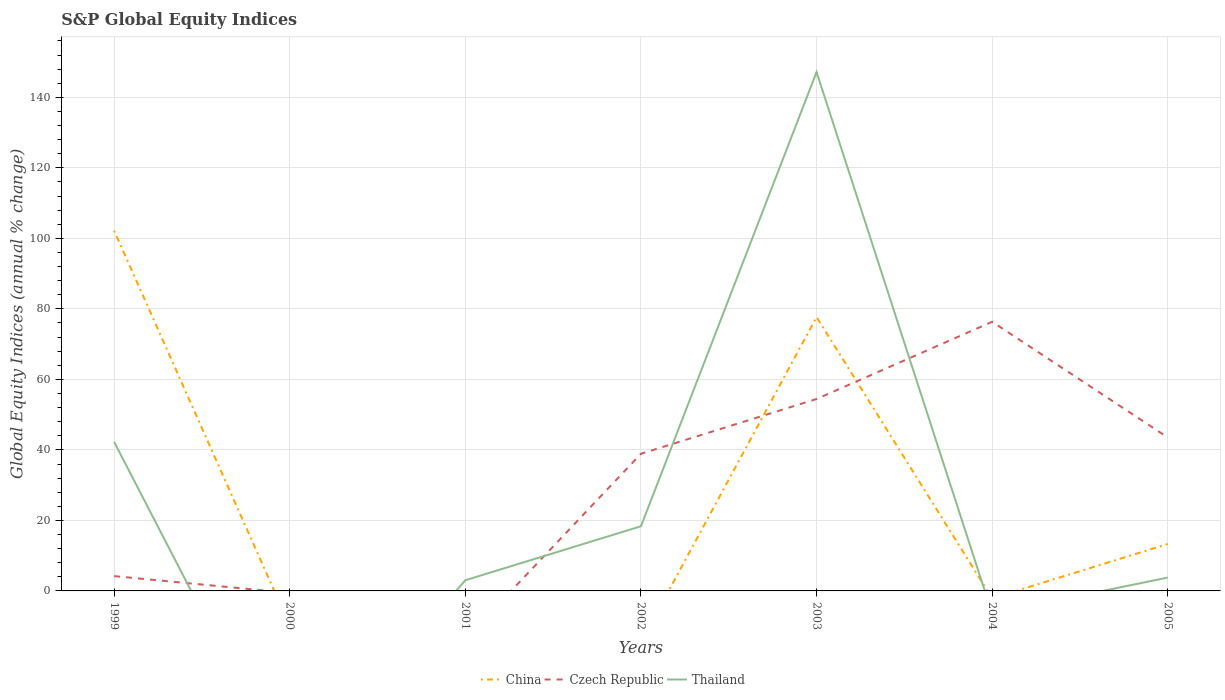Does the line corresponding to Czech Republic intersect with the line corresponding to Thailand?
Your answer should be very brief. Yes. Is the number of lines equal to the number of legend labels?
Offer a very short reply. No. What is the total global equity indices in Thailand in the graph?
Provide a succinct answer. -144.15. What is the difference between the highest and the second highest global equity indices in China?
Offer a very short reply. 102.2. How many lines are there?
Your answer should be compact. 3. How many years are there in the graph?
Provide a succinct answer. 7. Are the values on the major ticks of Y-axis written in scientific E-notation?
Your answer should be very brief. No. Does the graph contain grids?
Offer a terse response. Yes. How many legend labels are there?
Your answer should be compact. 3. How are the legend labels stacked?
Give a very brief answer. Horizontal. What is the title of the graph?
Your answer should be compact. S&P Global Equity Indices. What is the label or title of the X-axis?
Ensure brevity in your answer.  Years. What is the label or title of the Y-axis?
Offer a very short reply. Global Equity Indices (annual % change). What is the Global Equity Indices (annual % change) of China in 1999?
Your answer should be very brief. 102.2. What is the Global Equity Indices (annual % change) of Czech Republic in 1999?
Offer a terse response. 4.2. What is the Global Equity Indices (annual % change) of Thailand in 1999?
Offer a very short reply. 42.3. What is the Global Equity Indices (annual % change) of Thailand in 2000?
Give a very brief answer. 0. What is the Global Equity Indices (annual % change) in China in 2001?
Provide a short and direct response. 0. What is the Global Equity Indices (annual % change) in Thailand in 2001?
Your response must be concise. 3.03. What is the Global Equity Indices (annual % change) of China in 2002?
Your answer should be compact. 0. What is the Global Equity Indices (annual % change) of Czech Republic in 2002?
Provide a short and direct response. 38.9. What is the Global Equity Indices (annual % change) in Thailand in 2002?
Offer a very short reply. 18.34. What is the Global Equity Indices (annual % change) of China in 2003?
Provide a short and direct response. 77.67. What is the Global Equity Indices (annual % change) in Czech Republic in 2003?
Provide a succinct answer. 54.44. What is the Global Equity Indices (annual % change) in Thailand in 2003?
Give a very brief answer. 147.18. What is the Global Equity Indices (annual % change) of Czech Republic in 2004?
Your response must be concise. 76.34. What is the Global Equity Indices (annual % change) of China in 2005?
Make the answer very short. 13.31. What is the Global Equity Indices (annual % change) in Czech Republic in 2005?
Give a very brief answer. 43.52. What is the Global Equity Indices (annual % change) of Thailand in 2005?
Ensure brevity in your answer.  3.79. Across all years, what is the maximum Global Equity Indices (annual % change) of China?
Give a very brief answer. 102.2. Across all years, what is the maximum Global Equity Indices (annual % change) of Czech Republic?
Your answer should be compact. 76.34. Across all years, what is the maximum Global Equity Indices (annual % change) in Thailand?
Your answer should be compact. 147.18. Across all years, what is the minimum Global Equity Indices (annual % change) of China?
Your answer should be very brief. 0. Across all years, what is the minimum Global Equity Indices (annual % change) in Czech Republic?
Provide a short and direct response. 0. What is the total Global Equity Indices (annual % change) in China in the graph?
Make the answer very short. 193.18. What is the total Global Equity Indices (annual % change) in Czech Republic in the graph?
Your answer should be very brief. 217.4. What is the total Global Equity Indices (annual % change) of Thailand in the graph?
Give a very brief answer. 214.64. What is the difference between the Global Equity Indices (annual % change) in Thailand in 1999 and that in 2001?
Ensure brevity in your answer.  39.27. What is the difference between the Global Equity Indices (annual % change) of Czech Republic in 1999 and that in 2002?
Keep it short and to the point. -34.7. What is the difference between the Global Equity Indices (annual % change) of Thailand in 1999 and that in 2002?
Provide a succinct answer. 23.96. What is the difference between the Global Equity Indices (annual % change) in China in 1999 and that in 2003?
Make the answer very short. 24.53. What is the difference between the Global Equity Indices (annual % change) of Czech Republic in 1999 and that in 2003?
Your response must be concise. -50.24. What is the difference between the Global Equity Indices (annual % change) of Thailand in 1999 and that in 2003?
Your answer should be compact. -104.88. What is the difference between the Global Equity Indices (annual % change) in Czech Republic in 1999 and that in 2004?
Your answer should be compact. -72.14. What is the difference between the Global Equity Indices (annual % change) in China in 1999 and that in 2005?
Make the answer very short. 88.89. What is the difference between the Global Equity Indices (annual % change) in Czech Republic in 1999 and that in 2005?
Provide a succinct answer. -39.32. What is the difference between the Global Equity Indices (annual % change) of Thailand in 1999 and that in 2005?
Offer a terse response. 38.51. What is the difference between the Global Equity Indices (annual % change) in Thailand in 2001 and that in 2002?
Your response must be concise. -15.31. What is the difference between the Global Equity Indices (annual % change) of Thailand in 2001 and that in 2003?
Give a very brief answer. -144.15. What is the difference between the Global Equity Indices (annual % change) of Thailand in 2001 and that in 2005?
Offer a terse response. -0.76. What is the difference between the Global Equity Indices (annual % change) of Czech Republic in 2002 and that in 2003?
Make the answer very short. -15.54. What is the difference between the Global Equity Indices (annual % change) of Thailand in 2002 and that in 2003?
Provide a short and direct response. -128.84. What is the difference between the Global Equity Indices (annual % change) of Czech Republic in 2002 and that in 2004?
Your answer should be very brief. -37.44. What is the difference between the Global Equity Indices (annual % change) in Czech Republic in 2002 and that in 2005?
Provide a succinct answer. -4.62. What is the difference between the Global Equity Indices (annual % change) in Thailand in 2002 and that in 2005?
Your answer should be very brief. 14.55. What is the difference between the Global Equity Indices (annual % change) of Czech Republic in 2003 and that in 2004?
Your response must be concise. -21.9. What is the difference between the Global Equity Indices (annual % change) of China in 2003 and that in 2005?
Your response must be concise. 64.36. What is the difference between the Global Equity Indices (annual % change) of Czech Republic in 2003 and that in 2005?
Ensure brevity in your answer.  10.92. What is the difference between the Global Equity Indices (annual % change) of Thailand in 2003 and that in 2005?
Provide a short and direct response. 143.39. What is the difference between the Global Equity Indices (annual % change) in Czech Republic in 2004 and that in 2005?
Ensure brevity in your answer.  32.82. What is the difference between the Global Equity Indices (annual % change) in China in 1999 and the Global Equity Indices (annual % change) in Thailand in 2001?
Provide a succinct answer. 99.17. What is the difference between the Global Equity Indices (annual % change) of Czech Republic in 1999 and the Global Equity Indices (annual % change) of Thailand in 2001?
Offer a very short reply. 1.17. What is the difference between the Global Equity Indices (annual % change) of China in 1999 and the Global Equity Indices (annual % change) of Czech Republic in 2002?
Keep it short and to the point. 63.3. What is the difference between the Global Equity Indices (annual % change) in China in 1999 and the Global Equity Indices (annual % change) in Thailand in 2002?
Ensure brevity in your answer.  83.86. What is the difference between the Global Equity Indices (annual % change) in Czech Republic in 1999 and the Global Equity Indices (annual % change) in Thailand in 2002?
Your answer should be compact. -14.14. What is the difference between the Global Equity Indices (annual % change) of China in 1999 and the Global Equity Indices (annual % change) of Czech Republic in 2003?
Provide a short and direct response. 47.76. What is the difference between the Global Equity Indices (annual % change) of China in 1999 and the Global Equity Indices (annual % change) of Thailand in 2003?
Keep it short and to the point. -44.98. What is the difference between the Global Equity Indices (annual % change) in Czech Republic in 1999 and the Global Equity Indices (annual % change) in Thailand in 2003?
Give a very brief answer. -142.98. What is the difference between the Global Equity Indices (annual % change) of China in 1999 and the Global Equity Indices (annual % change) of Czech Republic in 2004?
Give a very brief answer. 25.86. What is the difference between the Global Equity Indices (annual % change) of China in 1999 and the Global Equity Indices (annual % change) of Czech Republic in 2005?
Keep it short and to the point. 58.68. What is the difference between the Global Equity Indices (annual % change) in China in 1999 and the Global Equity Indices (annual % change) in Thailand in 2005?
Ensure brevity in your answer.  98.41. What is the difference between the Global Equity Indices (annual % change) in Czech Republic in 1999 and the Global Equity Indices (annual % change) in Thailand in 2005?
Ensure brevity in your answer.  0.41. What is the difference between the Global Equity Indices (annual % change) in Czech Republic in 2002 and the Global Equity Indices (annual % change) in Thailand in 2003?
Keep it short and to the point. -108.28. What is the difference between the Global Equity Indices (annual % change) in Czech Republic in 2002 and the Global Equity Indices (annual % change) in Thailand in 2005?
Make the answer very short. 35.11. What is the difference between the Global Equity Indices (annual % change) in China in 2003 and the Global Equity Indices (annual % change) in Czech Republic in 2004?
Provide a short and direct response. 1.33. What is the difference between the Global Equity Indices (annual % change) in China in 2003 and the Global Equity Indices (annual % change) in Czech Republic in 2005?
Offer a very short reply. 34.15. What is the difference between the Global Equity Indices (annual % change) in China in 2003 and the Global Equity Indices (annual % change) in Thailand in 2005?
Make the answer very short. 73.88. What is the difference between the Global Equity Indices (annual % change) of Czech Republic in 2003 and the Global Equity Indices (annual % change) of Thailand in 2005?
Keep it short and to the point. 50.65. What is the difference between the Global Equity Indices (annual % change) of Czech Republic in 2004 and the Global Equity Indices (annual % change) of Thailand in 2005?
Keep it short and to the point. 72.55. What is the average Global Equity Indices (annual % change) of China per year?
Your answer should be compact. 27.6. What is the average Global Equity Indices (annual % change) in Czech Republic per year?
Provide a succinct answer. 31.06. What is the average Global Equity Indices (annual % change) of Thailand per year?
Keep it short and to the point. 30.66. In the year 1999, what is the difference between the Global Equity Indices (annual % change) in China and Global Equity Indices (annual % change) in Czech Republic?
Your answer should be compact. 98. In the year 1999, what is the difference between the Global Equity Indices (annual % change) of China and Global Equity Indices (annual % change) of Thailand?
Your answer should be very brief. 59.9. In the year 1999, what is the difference between the Global Equity Indices (annual % change) in Czech Republic and Global Equity Indices (annual % change) in Thailand?
Your answer should be compact. -38.1. In the year 2002, what is the difference between the Global Equity Indices (annual % change) of Czech Republic and Global Equity Indices (annual % change) of Thailand?
Provide a short and direct response. 20.56. In the year 2003, what is the difference between the Global Equity Indices (annual % change) of China and Global Equity Indices (annual % change) of Czech Republic?
Your answer should be very brief. 23.23. In the year 2003, what is the difference between the Global Equity Indices (annual % change) in China and Global Equity Indices (annual % change) in Thailand?
Ensure brevity in your answer.  -69.51. In the year 2003, what is the difference between the Global Equity Indices (annual % change) of Czech Republic and Global Equity Indices (annual % change) of Thailand?
Offer a very short reply. -92.74. In the year 2005, what is the difference between the Global Equity Indices (annual % change) of China and Global Equity Indices (annual % change) of Czech Republic?
Make the answer very short. -30.21. In the year 2005, what is the difference between the Global Equity Indices (annual % change) of China and Global Equity Indices (annual % change) of Thailand?
Provide a short and direct response. 9.52. In the year 2005, what is the difference between the Global Equity Indices (annual % change) in Czech Republic and Global Equity Indices (annual % change) in Thailand?
Offer a very short reply. 39.73. What is the ratio of the Global Equity Indices (annual % change) in Thailand in 1999 to that in 2001?
Keep it short and to the point. 13.97. What is the ratio of the Global Equity Indices (annual % change) of Czech Republic in 1999 to that in 2002?
Your answer should be very brief. 0.11. What is the ratio of the Global Equity Indices (annual % change) in Thailand in 1999 to that in 2002?
Your answer should be compact. 2.31. What is the ratio of the Global Equity Indices (annual % change) of China in 1999 to that in 2003?
Provide a short and direct response. 1.32. What is the ratio of the Global Equity Indices (annual % change) of Czech Republic in 1999 to that in 2003?
Ensure brevity in your answer.  0.08. What is the ratio of the Global Equity Indices (annual % change) of Thailand in 1999 to that in 2003?
Offer a very short reply. 0.29. What is the ratio of the Global Equity Indices (annual % change) of Czech Republic in 1999 to that in 2004?
Provide a short and direct response. 0.06. What is the ratio of the Global Equity Indices (annual % change) in China in 1999 to that in 2005?
Give a very brief answer. 7.68. What is the ratio of the Global Equity Indices (annual % change) in Czech Republic in 1999 to that in 2005?
Your response must be concise. 0.1. What is the ratio of the Global Equity Indices (annual % change) of Thailand in 1999 to that in 2005?
Give a very brief answer. 11.16. What is the ratio of the Global Equity Indices (annual % change) of Thailand in 2001 to that in 2002?
Provide a succinct answer. 0.17. What is the ratio of the Global Equity Indices (annual % change) in Thailand in 2001 to that in 2003?
Make the answer very short. 0.02. What is the ratio of the Global Equity Indices (annual % change) of Thailand in 2001 to that in 2005?
Give a very brief answer. 0.8. What is the ratio of the Global Equity Indices (annual % change) of Czech Republic in 2002 to that in 2003?
Keep it short and to the point. 0.71. What is the ratio of the Global Equity Indices (annual % change) in Thailand in 2002 to that in 2003?
Provide a succinct answer. 0.12. What is the ratio of the Global Equity Indices (annual % change) of Czech Republic in 2002 to that in 2004?
Keep it short and to the point. 0.51. What is the ratio of the Global Equity Indices (annual % change) of Czech Republic in 2002 to that in 2005?
Give a very brief answer. 0.89. What is the ratio of the Global Equity Indices (annual % change) of Thailand in 2002 to that in 2005?
Keep it short and to the point. 4.84. What is the ratio of the Global Equity Indices (annual % change) of Czech Republic in 2003 to that in 2004?
Your answer should be compact. 0.71. What is the ratio of the Global Equity Indices (annual % change) in China in 2003 to that in 2005?
Your response must be concise. 5.83. What is the ratio of the Global Equity Indices (annual % change) of Czech Republic in 2003 to that in 2005?
Provide a succinct answer. 1.25. What is the ratio of the Global Equity Indices (annual % change) in Thailand in 2003 to that in 2005?
Provide a succinct answer. 38.84. What is the ratio of the Global Equity Indices (annual % change) in Czech Republic in 2004 to that in 2005?
Your answer should be very brief. 1.75. What is the difference between the highest and the second highest Global Equity Indices (annual % change) of China?
Give a very brief answer. 24.53. What is the difference between the highest and the second highest Global Equity Indices (annual % change) in Czech Republic?
Offer a very short reply. 21.9. What is the difference between the highest and the second highest Global Equity Indices (annual % change) in Thailand?
Provide a short and direct response. 104.88. What is the difference between the highest and the lowest Global Equity Indices (annual % change) in China?
Give a very brief answer. 102.2. What is the difference between the highest and the lowest Global Equity Indices (annual % change) of Czech Republic?
Provide a succinct answer. 76.34. What is the difference between the highest and the lowest Global Equity Indices (annual % change) of Thailand?
Your answer should be very brief. 147.18. 